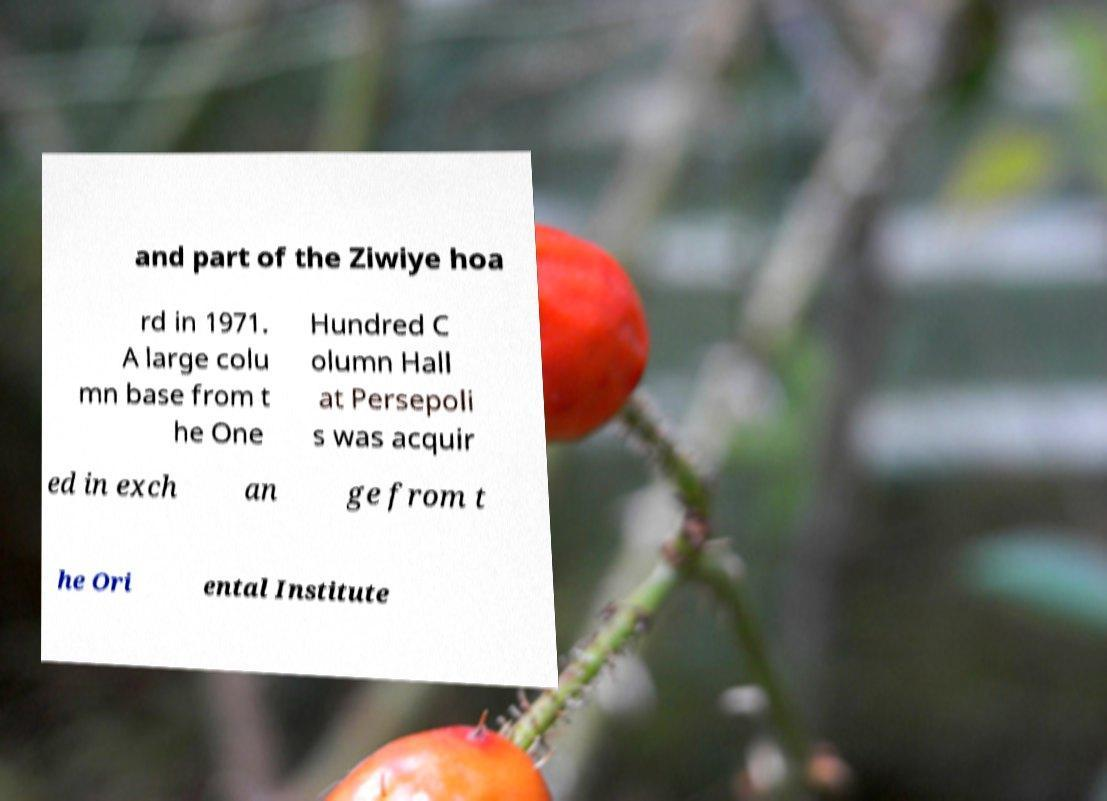Please identify and transcribe the text found in this image. and part of the Ziwiye hoa rd in 1971. A large colu mn base from t he One Hundred C olumn Hall at Persepoli s was acquir ed in exch an ge from t he Ori ental Institute 